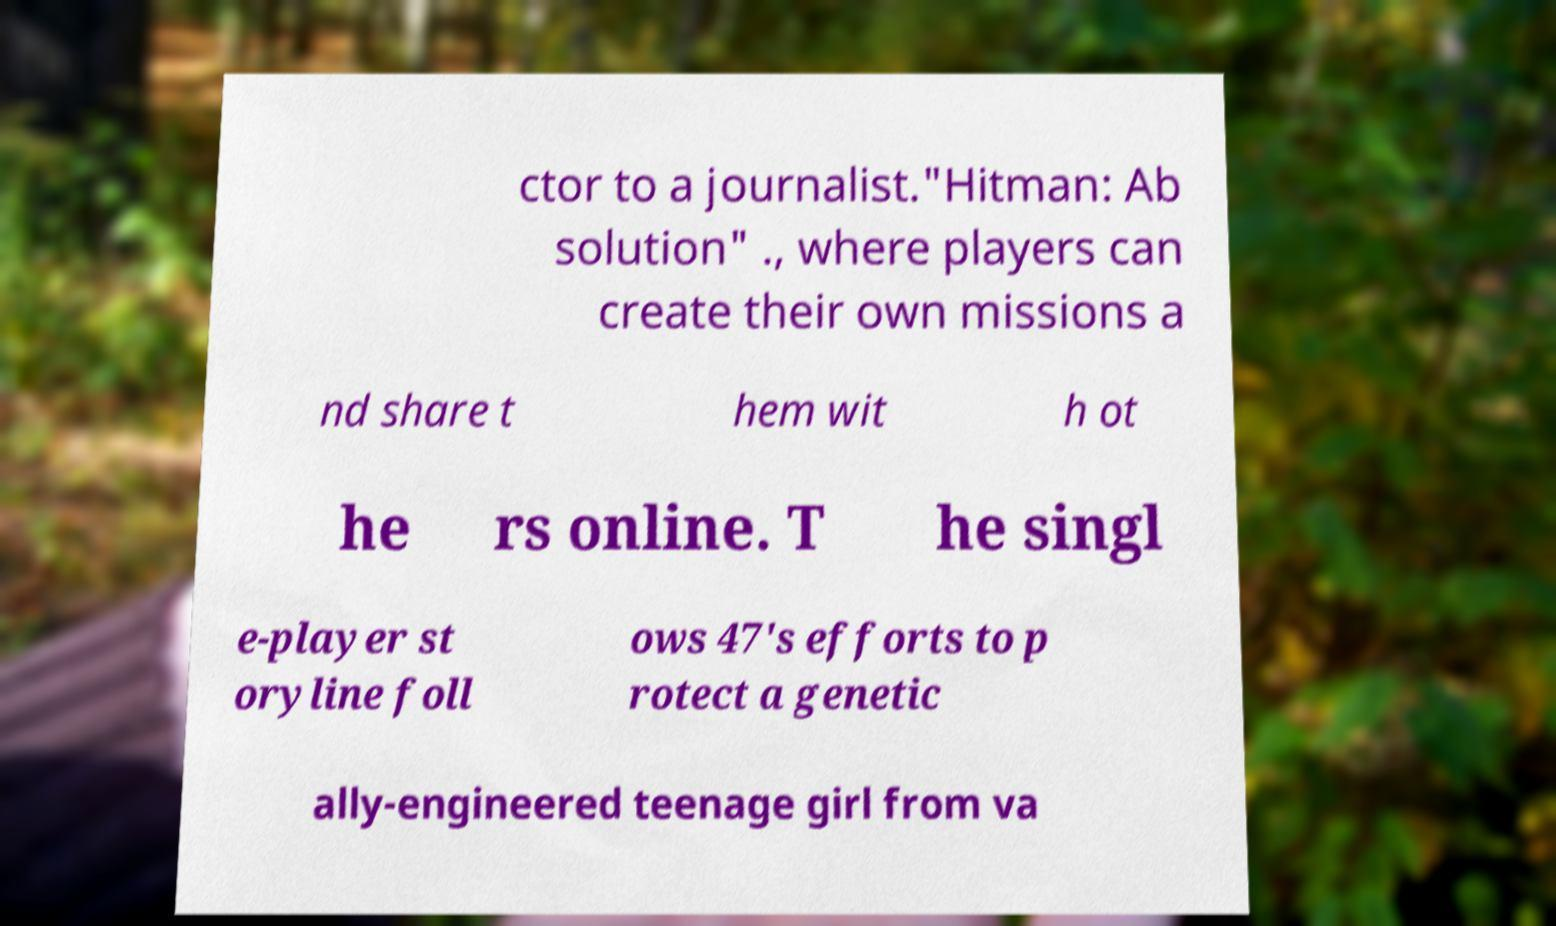I need the written content from this picture converted into text. Can you do that? ctor to a journalist."Hitman: Ab solution" ., where players can create their own missions a nd share t hem wit h ot he rs online. T he singl e-player st oryline foll ows 47's efforts to p rotect a genetic ally-engineered teenage girl from va 